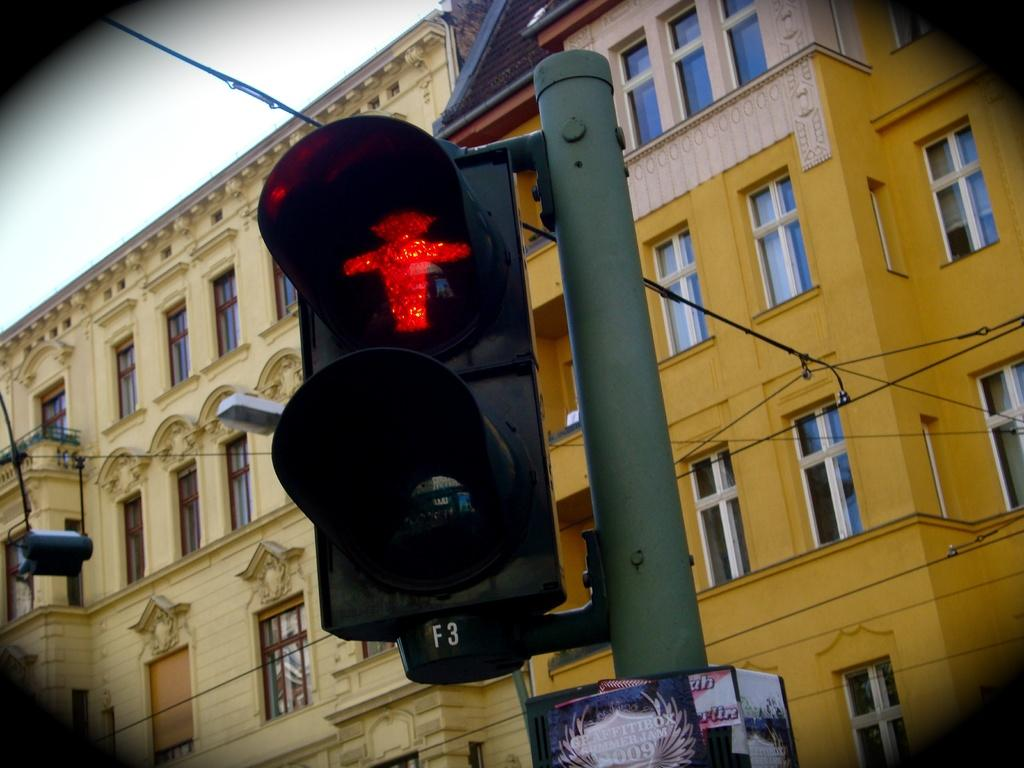What type of structures can be seen in the image? There are buildings in the image. What is attached to the pole in the image? There is a traffic signal light on a pole in the image. What is the condition of the sky in the image? The sky is cloudy in the image. What type of plant is growing on the shirt of the person in the image? There is no person or shirt present in the image, so it is not possible to determine if a plant is growing on a shirt. 